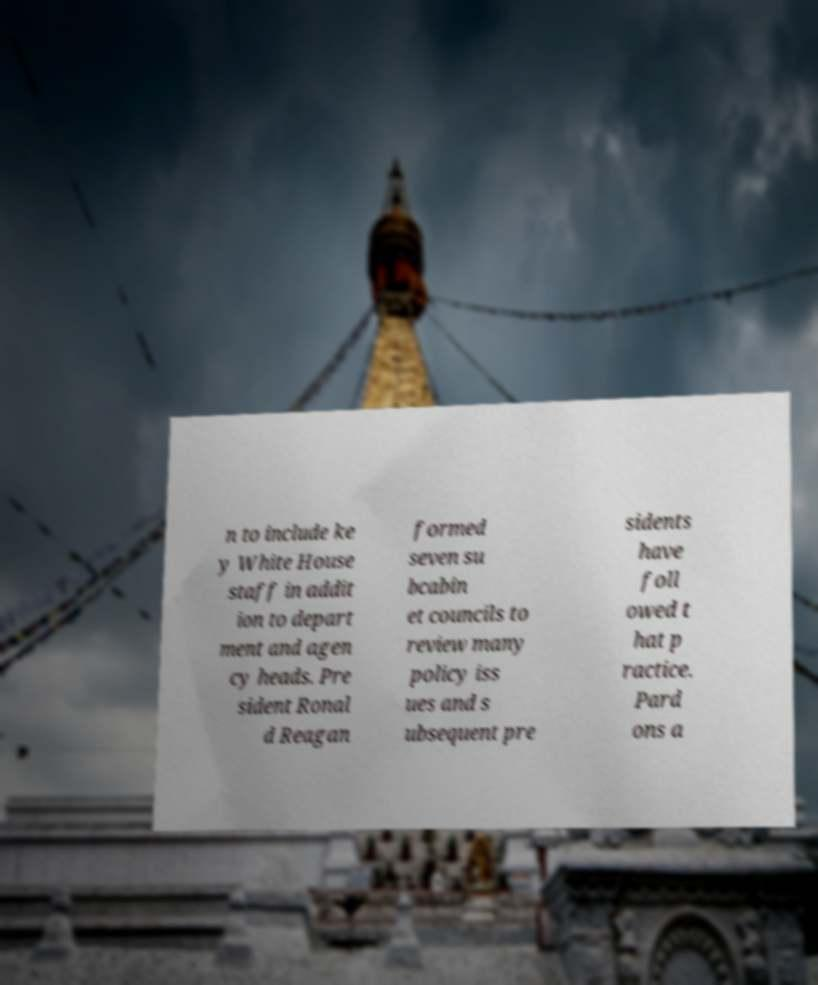Can you accurately transcribe the text from the provided image for me? n to include ke y White House staff in addit ion to depart ment and agen cy heads. Pre sident Ronal d Reagan formed seven su bcabin et councils to review many policy iss ues and s ubsequent pre sidents have foll owed t hat p ractice. Pard ons a 